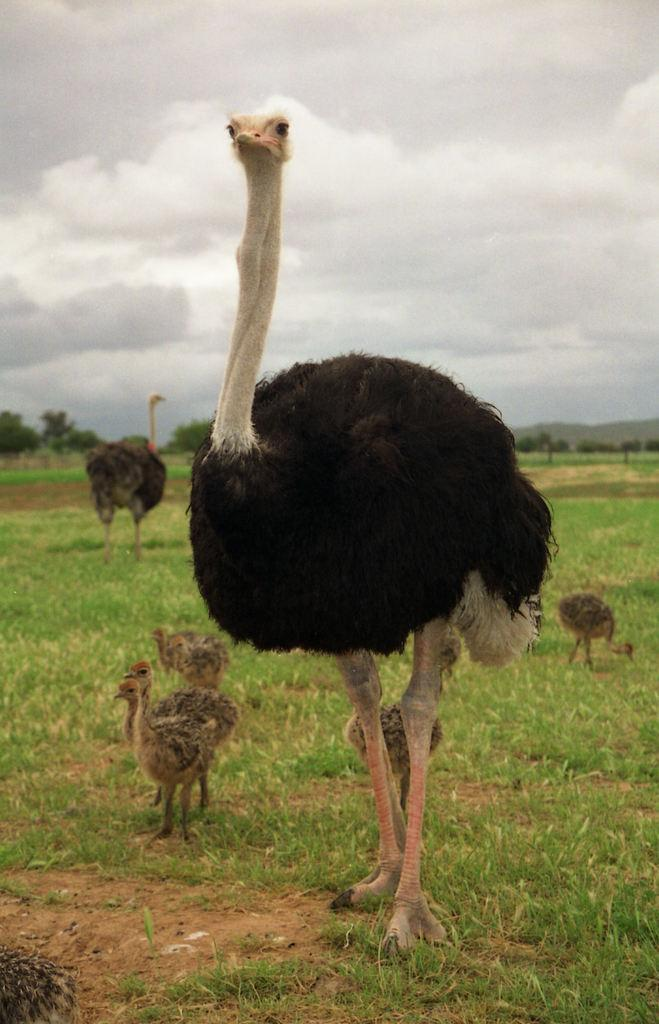What type of animals can be seen in the image? There are birds in the image. What is at the bottom of the image? There is grass at the bottom of the image. What can be seen in the background of the image? There are trees and the sky visible in the background of the image. What pump is being used by the birds in the image? There is no pump present in the image; it features birds in a natural setting. 